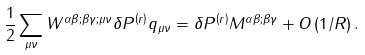<formula> <loc_0><loc_0><loc_500><loc_500>\frac { 1 } { 2 } \sum _ { \mu \nu } W ^ { \alpha \beta ; \beta \gamma ; \mu \nu } \delta P ^ { \left ( r \right ) } q _ { \mu \nu } = \delta P ^ { \left ( r \right ) } M ^ { \alpha \beta ; \beta \gamma } + O \left ( 1 / R \right ) .</formula> 